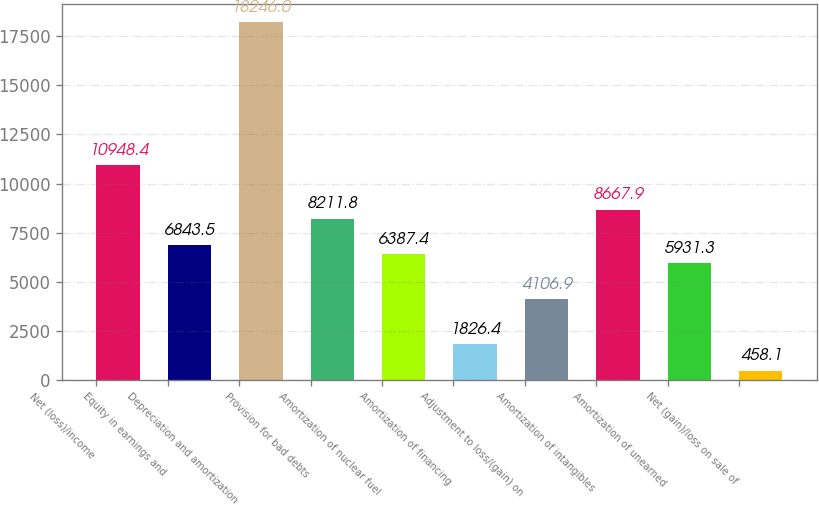<chart> <loc_0><loc_0><loc_500><loc_500><bar_chart><fcel>Net (loss)/income<fcel>Equity in earnings and<fcel>Depreciation and amortization<fcel>Provision for bad debts<fcel>Amortization of nuclear fuel<fcel>Amortization of financing<fcel>Adjustment to loss/(gain) on<fcel>Amortization of intangibles<fcel>Amortization of unearned<fcel>Net (gain)/loss on sale of<nl><fcel>10948.4<fcel>6843.5<fcel>18246<fcel>8211.8<fcel>6387.4<fcel>1826.4<fcel>4106.9<fcel>8667.9<fcel>5931.3<fcel>458.1<nl></chart> 